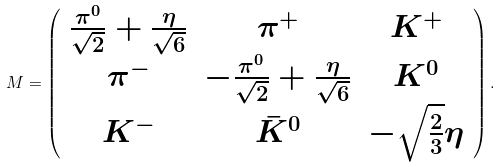<formula> <loc_0><loc_0><loc_500><loc_500>M = \left ( \begin{array} { c c c } \frac { \pi ^ { 0 } } { \sqrt { 2 } } + \frac { \eta } { \sqrt { 6 } } & \pi ^ { + } & K ^ { + } \\ \pi ^ { - } & - \frac { \pi ^ { 0 } } { \sqrt { 2 } } + \frac { \eta } { \sqrt { 6 } } & K ^ { 0 } \\ K ^ { - } & \bar { K } ^ { 0 } & - \sqrt { \frac { 2 } { 3 } } \eta \end{array} \right ) .</formula> 